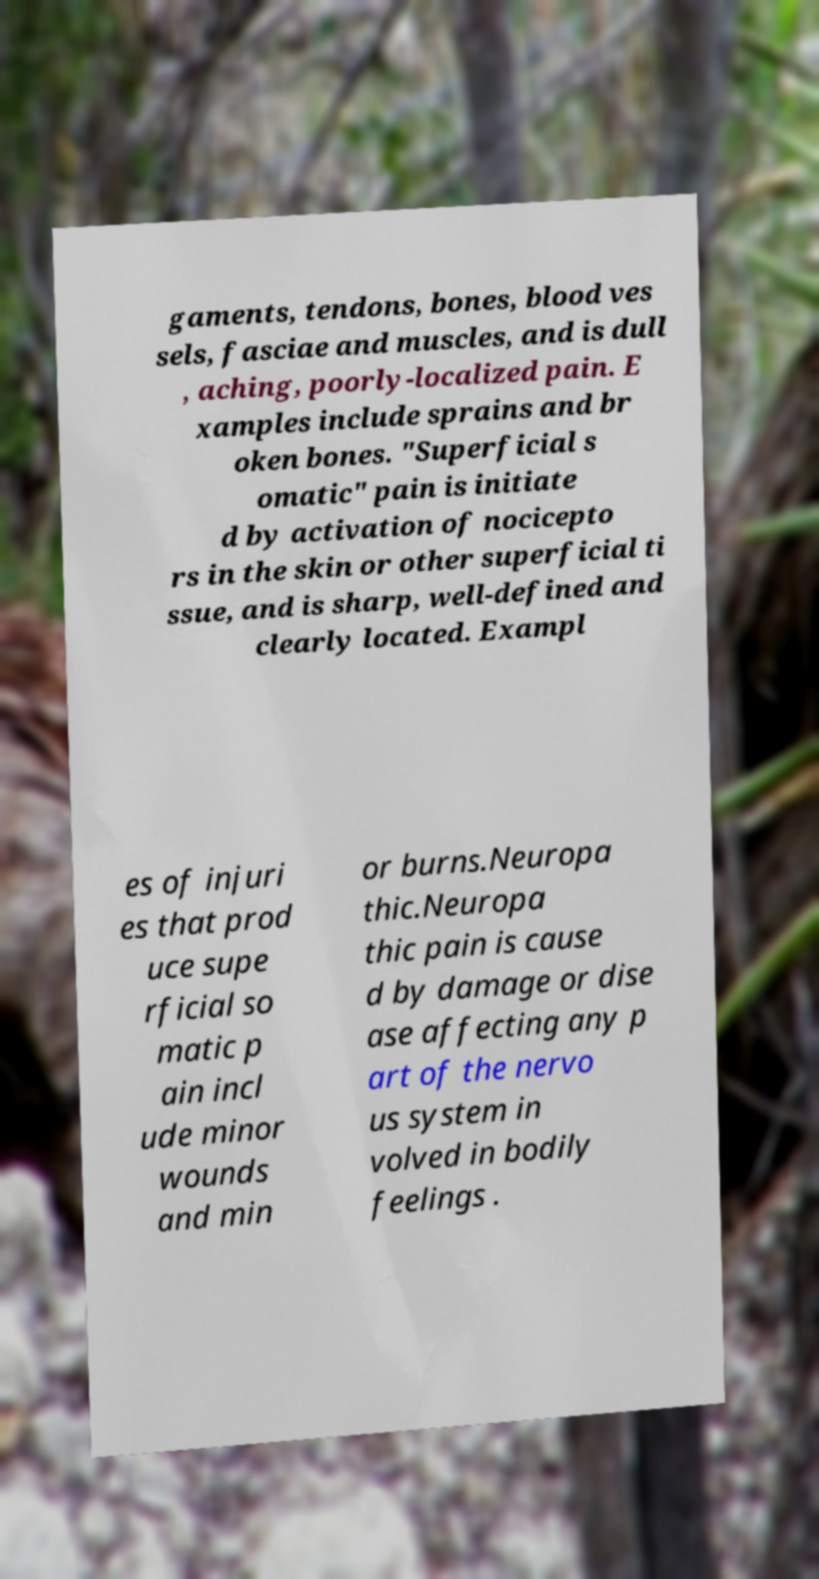I need the written content from this picture converted into text. Can you do that? gaments, tendons, bones, blood ves sels, fasciae and muscles, and is dull , aching, poorly-localized pain. E xamples include sprains and br oken bones. "Superficial s omatic" pain is initiate d by activation of nocicepto rs in the skin or other superficial ti ssue, and is sharp, well-defined and clearly located. Exampl es of injuri es that prod uce supe rficial so matic p ain incl ude minor wounds and min or burns.Neuropa thic.Neuropa thic pain is cause d by damage or dise ase affecting any p art of the nervo us system in volved in bodily feelings . 